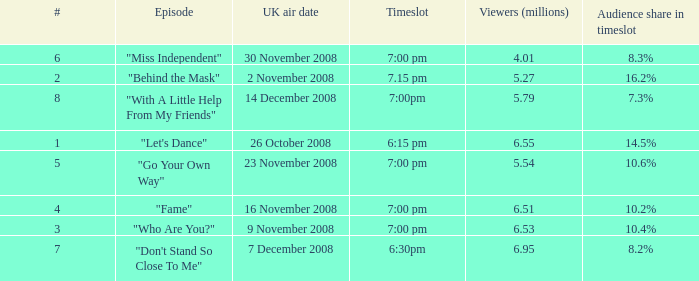Name the total number of viewers for audience share in timeslot for 10.2% 1.0. Write the full table. {'header': ['#', 'Episode', 'UK air date', 'Timeslot', 'Viewers (millions)', 'Audience share in timeslot'], 'rows': [['6', '"Miss Independent"', '30 November 2008', '7:00 pm', '4.01', '8.3%'], ['2', '"Behind the Mask"', '2 November 2008', '7.15 pm', '5.27', '16.2%'], ['8', '"With A Little Help From My Friends"', '14 December 2008', '7:00pm', '5.79', '7.3%'], ['1', '"Let\'s Dance"', '26 October 2008', '6:15 pm', '6.55', '14.5%'], ['5', '"Go Your Own Way"', '23 November 2008', '7:00 pm', '5.54', '10.6%'], ['4', '"Fame"', '16 November 2008', '7:00 pm', '6.51', '10.2%'], ['3', '"Who Are You?"', '9 November 2008', '7:00 pm', '6.53', '10.4%'], ['7', '"Don\'t Stand So Close To Me"', '7 December 2008', '6:30pm', '6.95', '8.2%']]} 